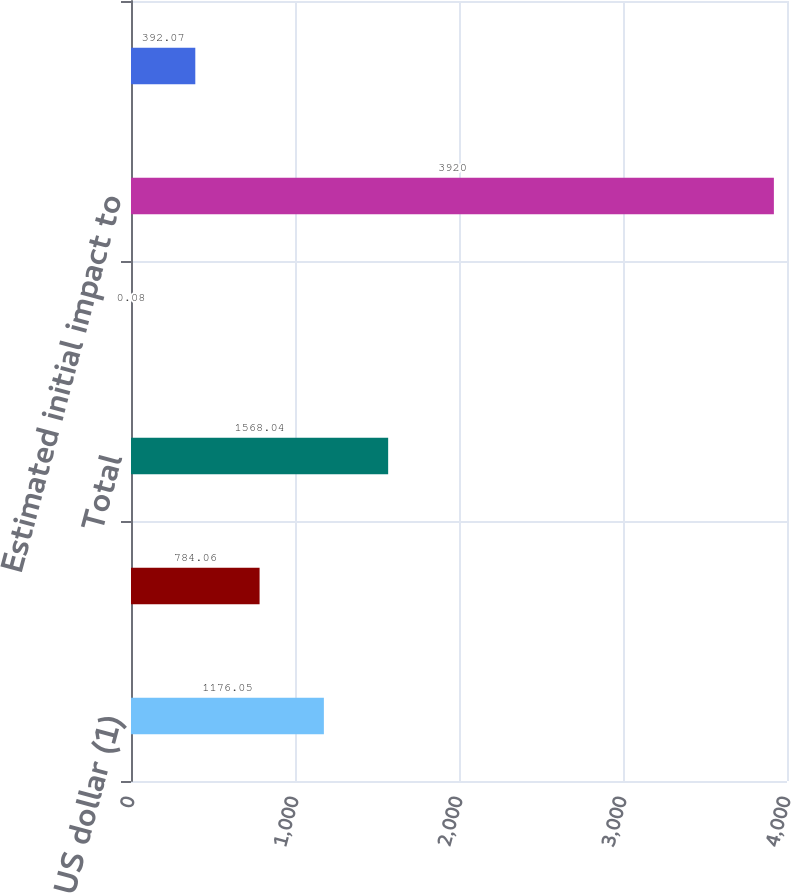Convert chart. <chart><loc_0><loc_0><loc_500><loc_500><bar_chart><fcel>US dollar (1)<fcel>All other currencies<fcel>Total<fcel>As a percentage of average<fcel>Estimated initial impact to<fcel>Estimated initial impact on<nl><fcel>1176.05<fcel>784.06<fcel>1568.04<fcel>0.08<fcel>3920<fcel>392.07<nl></chart> 